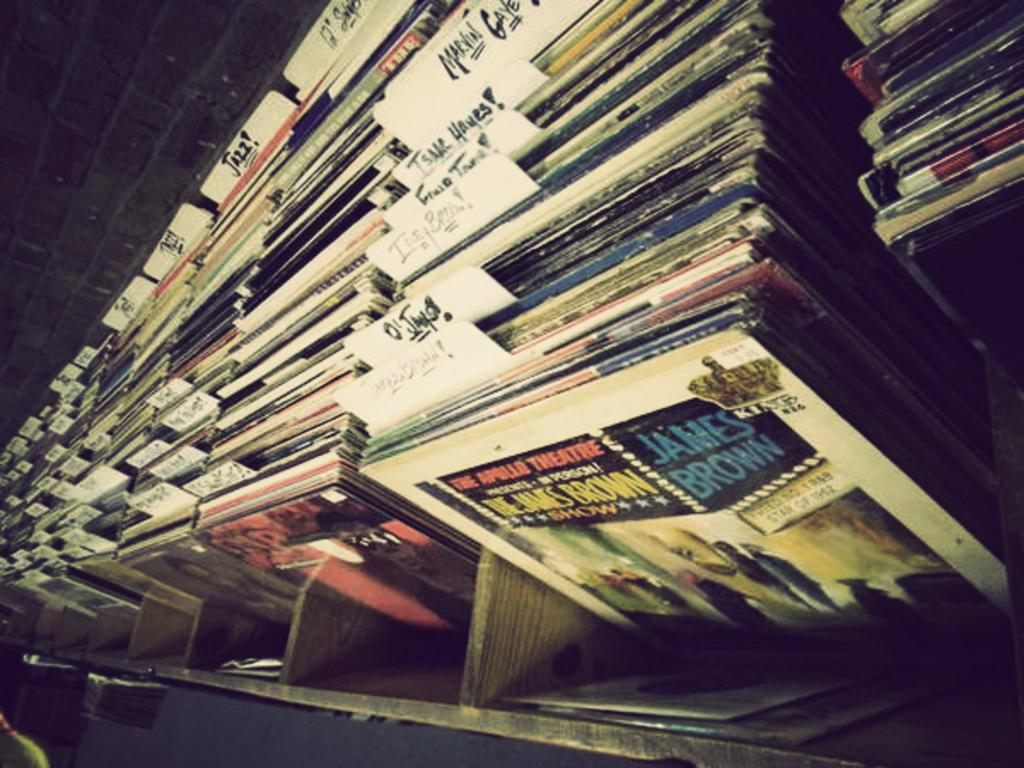<image>
Present a compact description of the photo's key features. A stack of records has one by James Brown in front. 